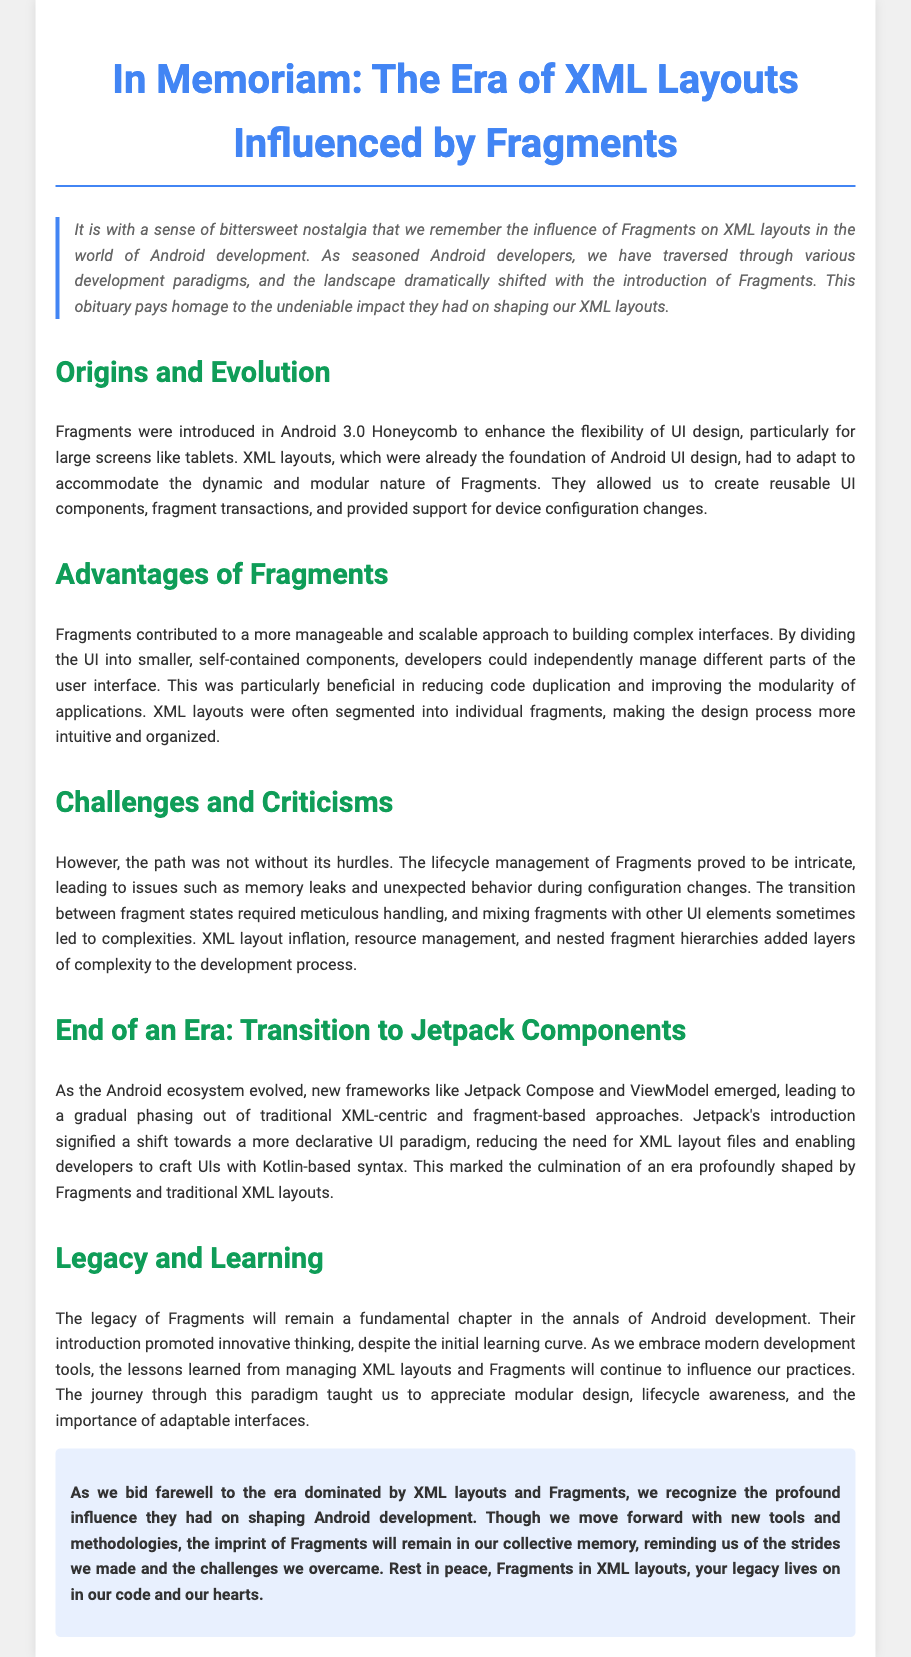What year were Fragments introduced? Fragments were introduced in Android 3.0 Honeycomb, as mentioned in the document.
Answer: 3.0 Honeycomb What is a primary advantage of using Fragments? The document states that Fragments contributed to a more manageable and scalable approach to building complex interfaces.
Answer: Manageable and scalable What major framework is mentioned as a successor to Fragments? The document references Jetpack components as a new framework that emerged, signaling the transition away from XML layouts and fragments.
Answer: Jetpack What challenge related to Fragments is highlighted in the document? The document mentions lifecycle management of Fragments as a significant challenge, causing memory leaks and unexpected behavior.
Answer: Lifecycle management What was a key lesson learned from working with Fragments according to the document? The document indicates that the journey through this paradigm taught an appreciation for modular design.
Answer: Modular design What kind of design was emphasized by the introduction of Fragments? The document emphasizes the modularity and adaptability of interfaces as important characteristics brought by Fragments.
Answer: Modularity and adaptability In which section is the impact of Fragments on Android development discussed? The section directly addresses the legacy and learning from Fragments within the context of Android development.
Answer: Legacy and Learning How does the document conclude regarding the legacy of Fragments? The conclusion states that even as we move on, the imprint of Fragments will remain in our memory.
Answer: Legacy lives on 